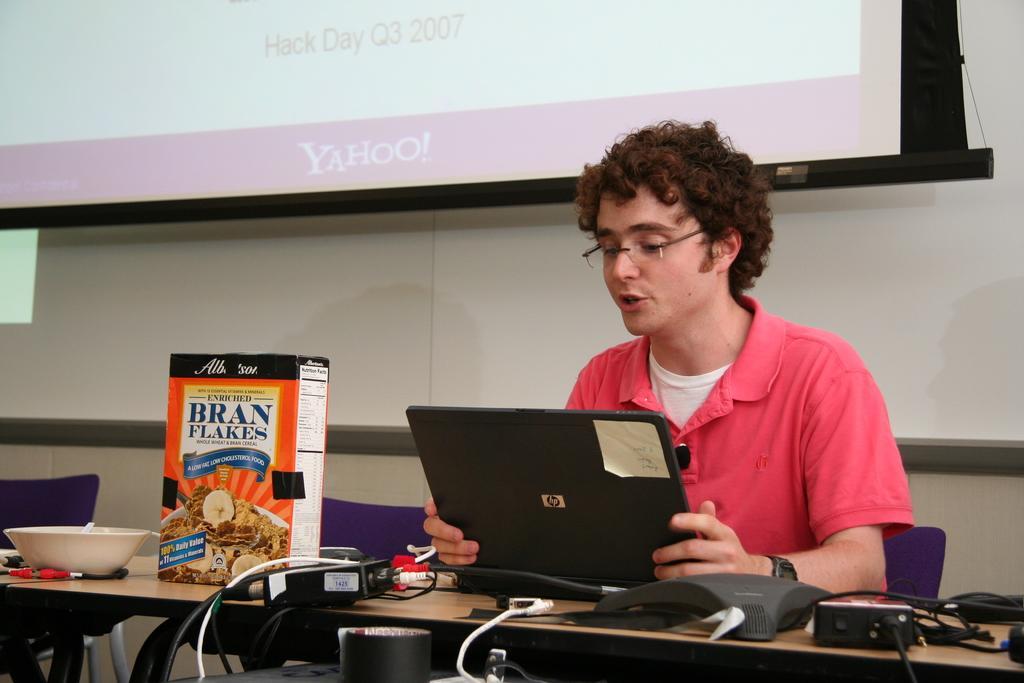Describe this image in one or two sentences. In the image we can see one person sitting on the chair. in front there is a table on table we can see tab,box written as "Corn Flakes",bowl,wired,mouse,tape etc. in the background there is a screen,wall and few empty chairs. 